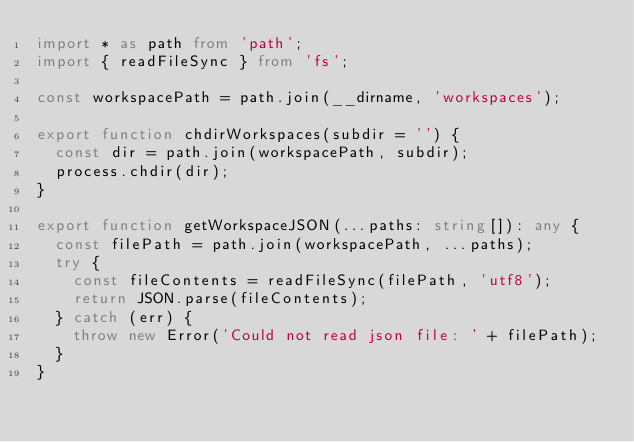Convert code to text. <code><loc_0><loc_0><loc_500><loc_500><_TypeScript_>import * as path from 'path';
import { readFileSync } from 'fs';

const workspacePath = path.join(__dirname, 'workspaces');

export function chdirWorkspaces(subdir = '') {
  const dir = path.join(workspacePath, subdir);
  process.chdir(dir);
}

export function getWorkspaceJSON(...paths: string[]): any {
  const filePath = path.join(workspacePath, ...paths);
  try {
    const fileContents = readFileSync(filePath, 'utf8');
    return JSON.parse(fileContents);
  } catch (err) {
    throw new Error('Could not read json file: ' + filePath);
  }
}
</code> 